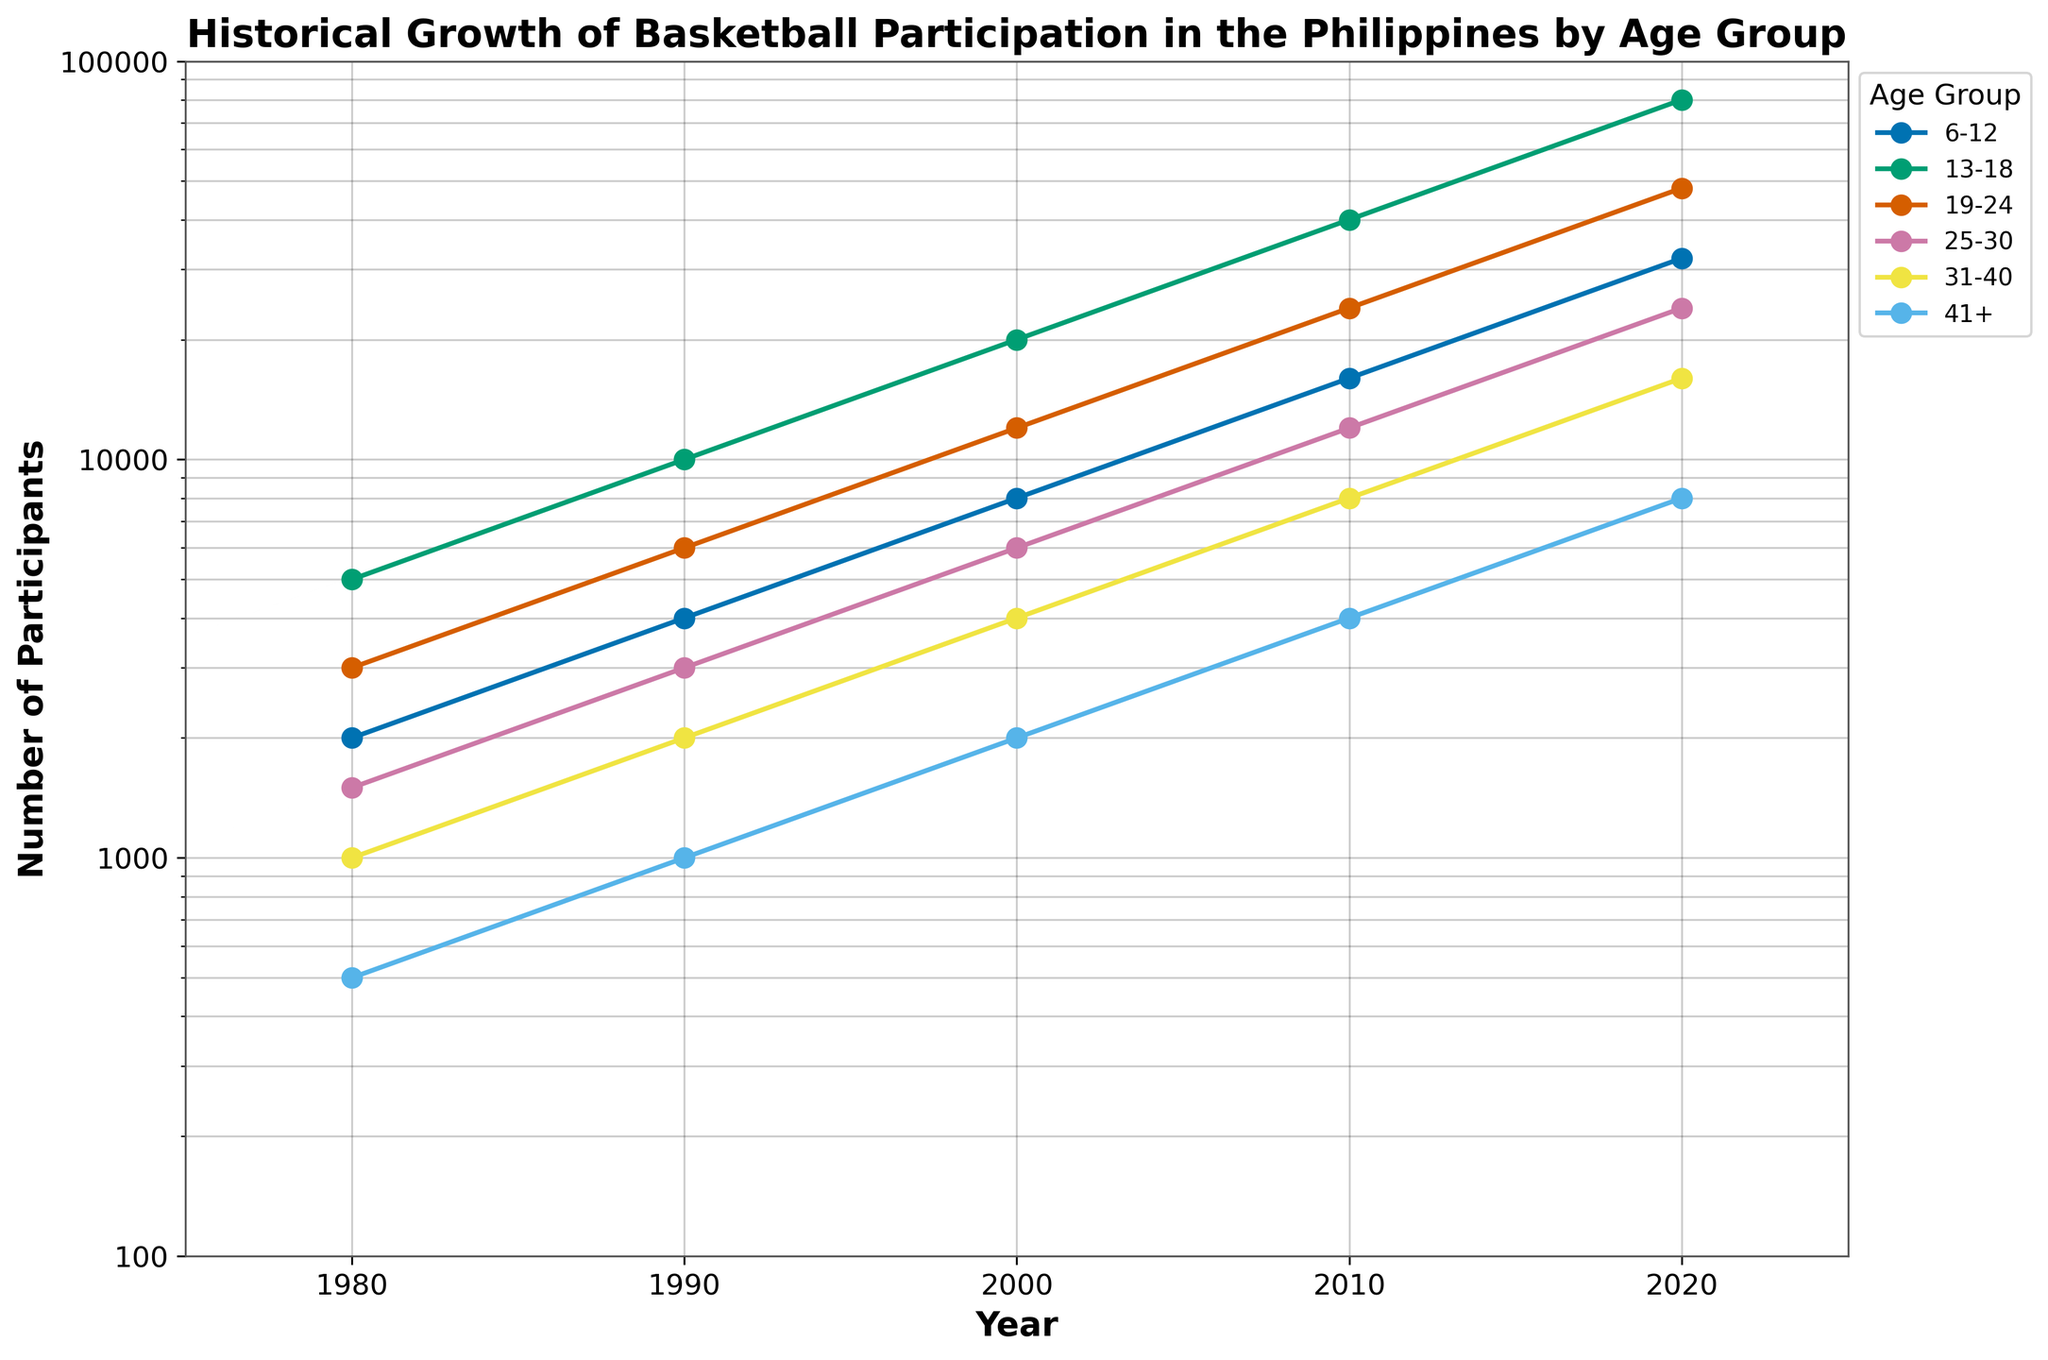What is the title of the figure? The title of the figure is typically positioned at the top and is indicated by a larger and bold font.
Answer: Historical Growth of Basketball Participation in the Philippines by Age Group Which age group had the highest number of participants in 2020? By looking at the data points and lines for the year 2020 on the x-axis, the highest value on the y-axis should be identified for each age group.
Answer: 13-18 How many participants were there in the 19-24 age group in 1990? Find the line corresponding to the 19-24 age group and look at the value at the intersection with the year 1990 on the x-axis.
Answer: 6000 What is the general trend of basketball participation across all age groups from 1980 to 2020? By visually inspecting the lines for all age groups, we can see if they are increasing, decreasing, or staying constant over time.
Answer: Increasing Compare the growth rate of the 6-12 age group with the 41+ age group from 1980 to 2020. Which one increased more rapidly? Calculate the ratio of the participants for 2020 to those in 1980 for both age groups and compare the ratios.
Answer: 6-12 For which age group did basketball participation increase the most from 1980 to 2000? Compare the differences in the number of participants between 1980 and 2000 for all age groups and find the one with the largest increase.
Answer: 13-18 How does the plot's use of a logarithmic scale help in visualizing the data? Discuss how a logarithmic scale, which represents exponential growth more visibly, helps to differentiate trends across different magnitudes on the y-axis.
Answer: It makes it easier to see the relative growth rates across multiple orders of magnitude Identify the age group with the least number of participants in 1980 and 2020. Are they the same? Look at the values for all age groups in both 1980 and 2020 and identify the minimum for each year. Compare the results to see if they are the same or different.
Answer: 41+ in 1980, 41+ in 2020 What is the ratio of participants in the 13-18 age group in 2020 to those in 1980? Divide the number of participants in 2020 by the number of participants in 1980 for the 13-18 age group.
Answer: 16:1 